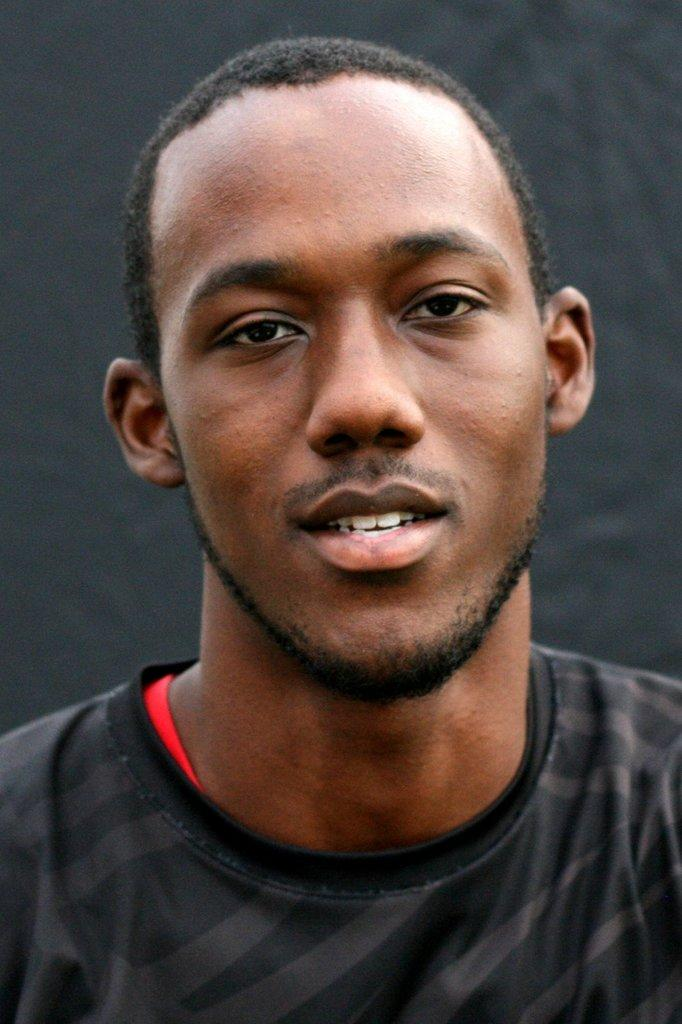What is the main subject of the image? There is a picture of a man in the image. What is the man wearing in the image? The man is wearing a black t-shirt in the image. What color is the background of the image? The background of the image is ash-colored. What type of lettuce can be seen in the image? There is no lettuce present in the image. How many knives are visible in the image? There are no knives visible in the image. 